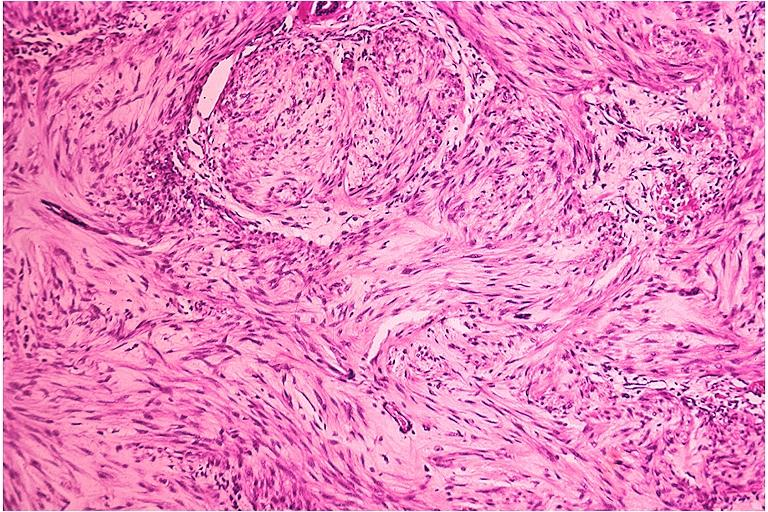where is this?
Answer the question using a single word or phrase. Oral 